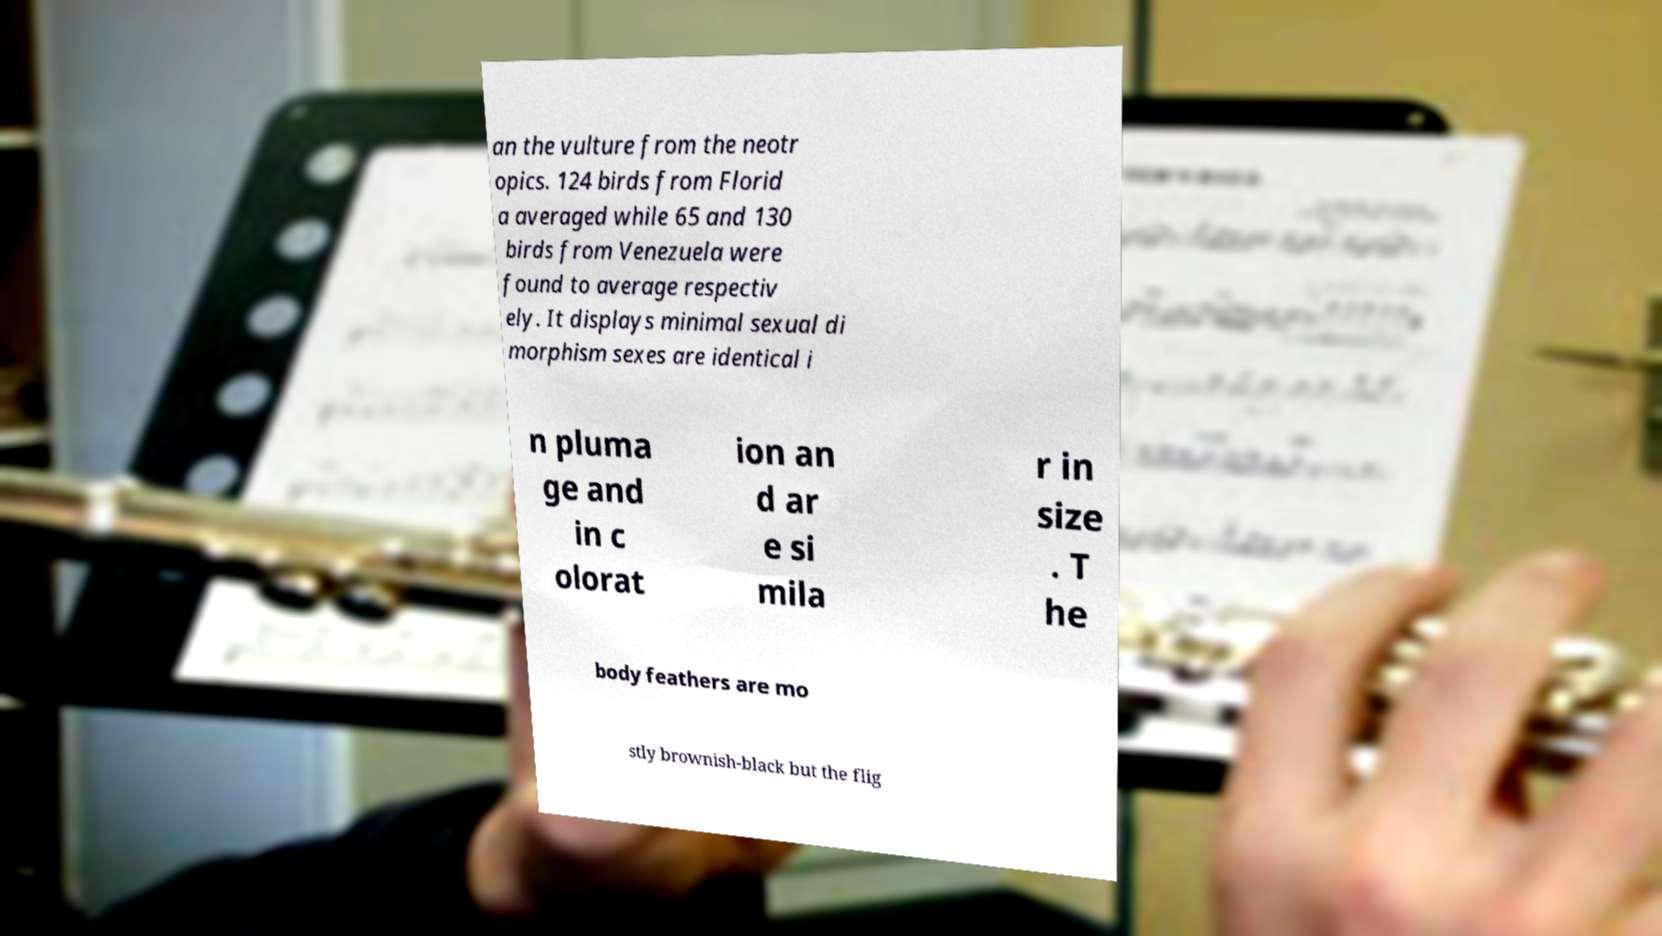Please identify and transcribe the text found in this image. an the vulture from the neotr opics. 124 birds from Florid a averaged while 65 and 130 birds from Venezuela were found to average respectiv ely. It displays minimal sexual di morphism sexes are identical i n pluma ge and in c olorat ion an d ar e si mila r in size . T he body feathers are mo stly brownish-black but the flig 